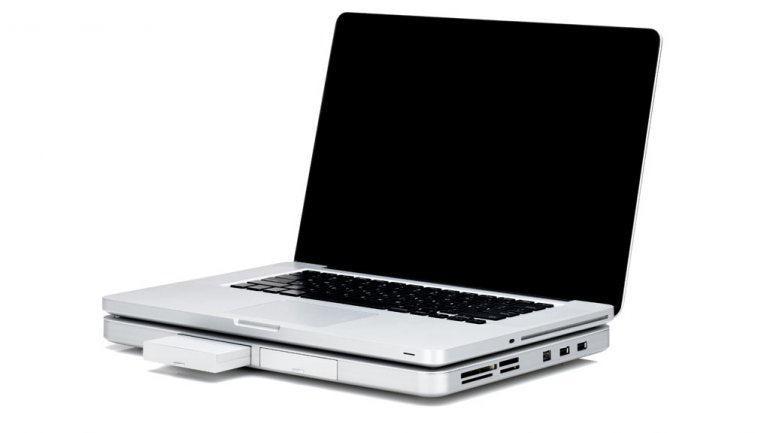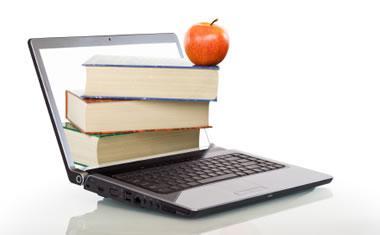The first image is the image on the left, the second image is the image on the right. Given the left and right images, does the statement "There are 3 or more books being displayed with laptops." hold true? Answer yes or no. Yes. The first image is the image on the left, the second image is the image on the right. Considering the images on both sides, is "There is one computer mouse in these." valid? Answer yes or no. No. 